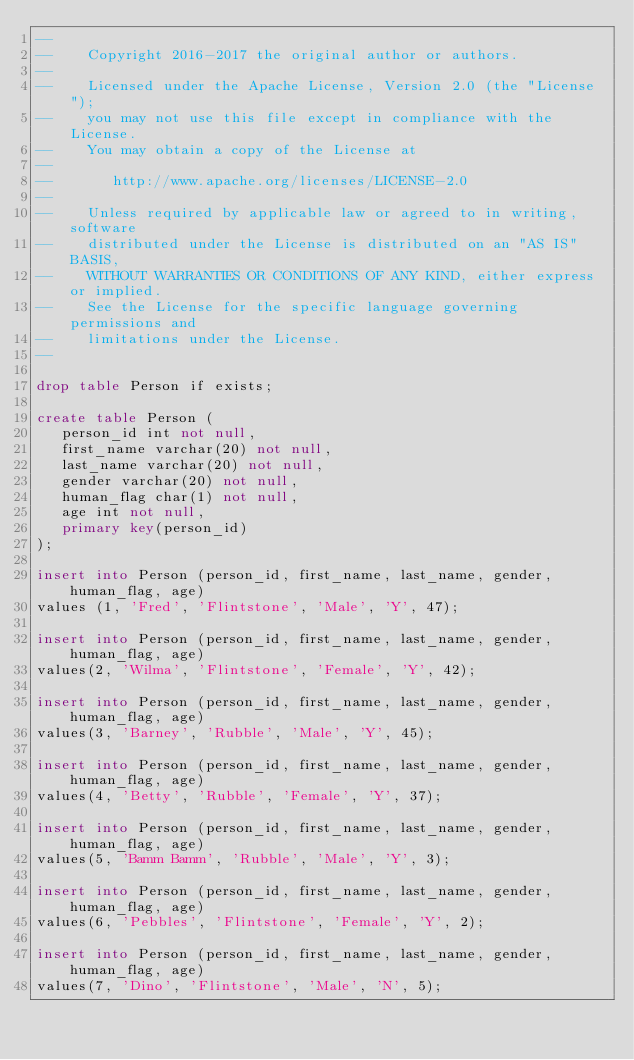Convert code to text. <code><loc_0><loc_0><loc_500><loc_500><_SQL_>--
--    Copyright 2016-2017 the original author or authors.
--
--    Licensed under the Apache License, Version 2.0 (the "License");
--    you may not use this file except in compliance with the License.
--    You may obtain a copy of the License at
--
--       http://www.apache.org/licenses/LICENSE-2.0
--
--    Unless required by applicable law or agreed to in writing, software
--    distributed under the License is distributed on an "AS IS" BASIS,
--    WITHOUT WARRANTIES OR CONDITIONS OF ANY KIND, either express or implied.
--    See the License for the specific language governing permissions and
--    limitations under the License.
--

drop table Person if exists;

create table Person (
   person_id int not null,
   first_name varchar(20) not null,
   last_name varchar(20) not null,
   gender varchar(20) not null,
   human_flag char(1) not null,
   age int not null,
   primary key(person_id)
);

insert into Person (person_id, first_name, last_name, gender, human_flag, age)
values (1, 'Fred', 'Flintstone', 'Male', 'Y', 47);

insert into Person (person_id, first_name, last_name, gender, human_flag, age)
values(2, 'Wilma', 'Flintstone', 'Female', 'Y', 42);

insert into Person (person_id, first_name, last_name, gender, human_flag, age)
values(3, 'Barney', 'Rubble', 'Male', 'Y', 45);

insert into Person (person_id, first_name, last_name, gender, human_flag, age)
values(4, 'Betty', 'Rubble', 'Female', 'Y', 37);

insert into Person (person_id, first_name, last_name, gender, human_flag, age)
values(5, 'Bamm Bamm', 'Rubble', 'Male', 'Y', 3);

insert into Person (person_id, first_name, last_name, gender, human_flag, age)
values(6, 'Pebbles', 'Flintstone', 'Female', 'Y', 2);

insert into Person (person_id, first_name, last_name, gender, human_flag, age)
values(7, 'Dino', 'Flintstone', 'Male', 'N', 5);
</code> 